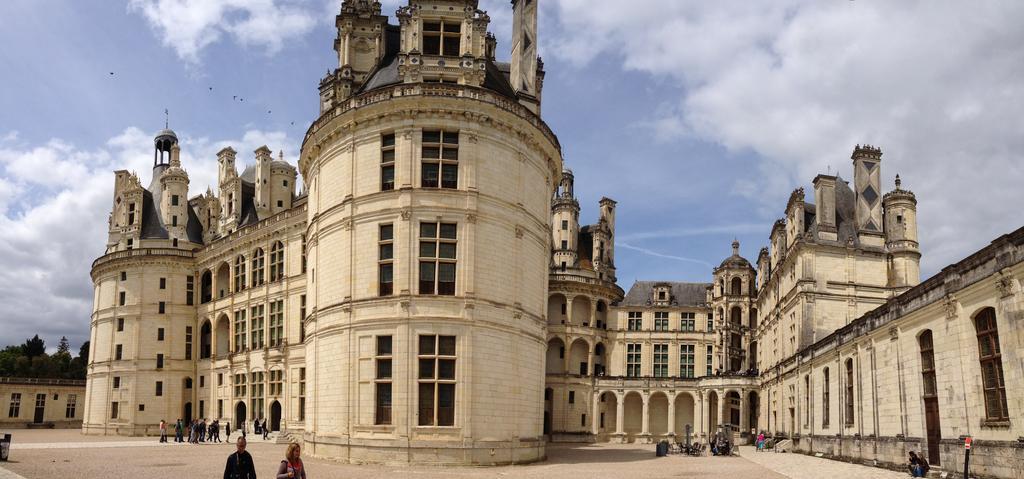Can you describe this image briefly? In the picture I can see buildings and people walking on the ground. I can also see poles and some other objects on the ground. In the background I can see trees, birds flying in the air and the sky. 